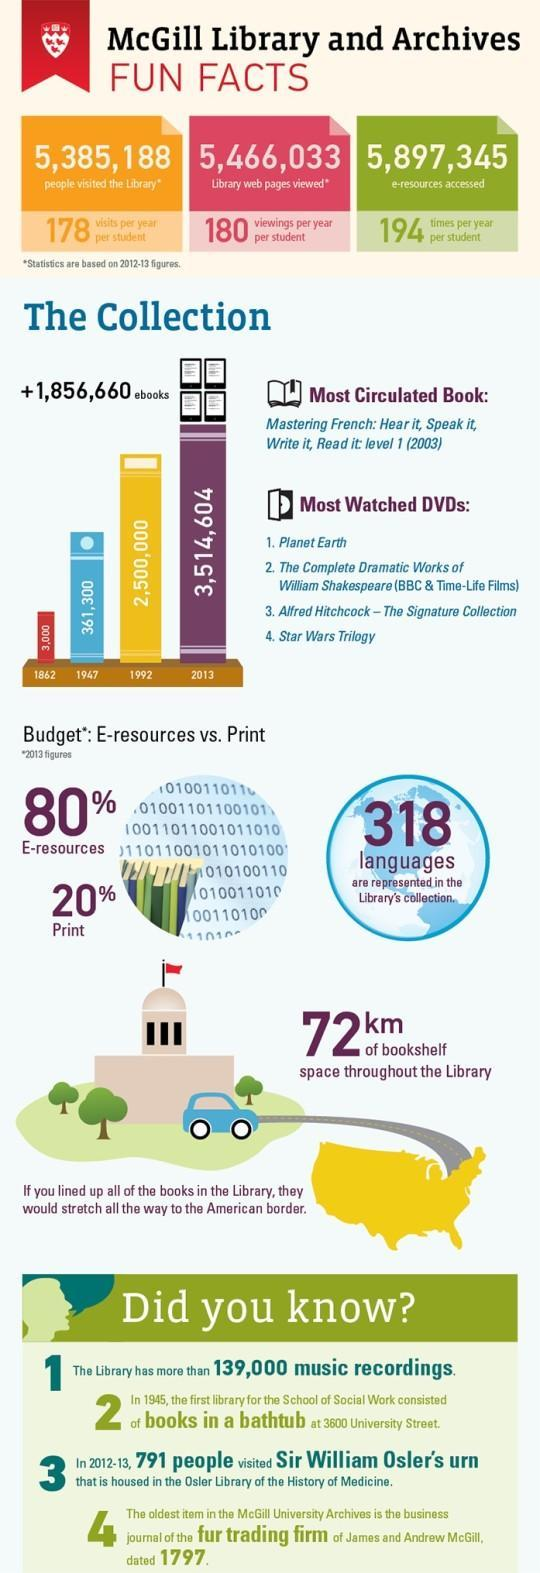How many e-books collections were available in the McGill Library in 2013?
Answer the question with a short phrase. 3,514,604 How many people visited the McGill Library in 2012-13? 5,385,188 How many e-resources were accessed in the McGill Library during 2012-13? 5,897,345 What is the percentage of printed books available in the McGill Library in 2013? 20% 